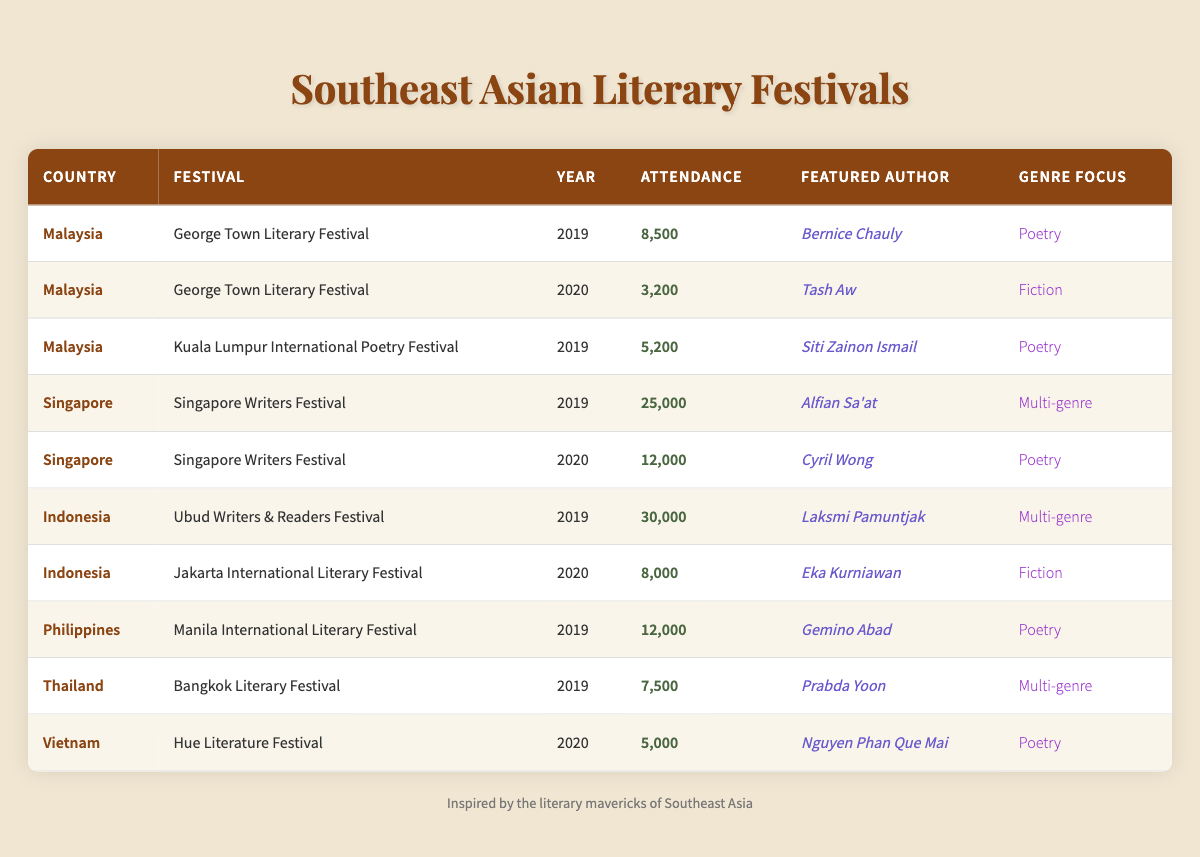What was the attendance at the George Town Literary Festival in 2019? According to the table, the George Town Literary Festival in 2019 had an attendance of 8,500.
Answer: 8,500 How many attendees did the Ubud Writers & Readers Festival have in 2019? The table shows that the Ubud Writers & Readers Festival in 2019 had an attendance of 30,000.
Answer: 30,000 Which country had the highest attendance at a literary festival in 2019? Looking at the attendance numbers for 2019, Indonesia recorded the highest with the Ubud Writers & Readers Festival having 30,000 attendees.
Answer: Indonesia What is the total attendance for Malaysian literary festivals listed in the table? Summing up the attendance from the George Town Literary Festival (8,500 + 3,200) and the Kuala Lumpur International Poetry Festival (5,200), the total attendance for Malaysian festivals is 8,500 + 3,200 + 5,200 = 16,900.
Answer: 16,900 Did the attendance increase from 2019 to 2020 for the Singapore Writers Festival? Comparing the attendance for the Singapore Writers Festival, it had 25,000 in 2019 and 12,000 in 2020. Since 12,000 is less than 25,000, the attendance did not increase.
Answer: No Which festival had a genre focus on Poetry and the highest attendance? The Ubud Writers & Readers Festival, which focuses on Multi-genre, is not relevant, so we look at the George Town Literary Festival (8,500) and Manila International Literary Festival (12,000). The Manila International Literary Festival had the highest attendance with 12,000 focusing on Poetry.
Answer: Manila International Literary Festival What was the average attendance across all literary festivals listed in the table? To find the average, first sum the attendance: (8500 + 3200 + 5200 + 25000 + 12000 + 30000 + 8000 + 12000 + 7500 + 5000) = 99300. There are 10 festivals, so the average attendance is 99300 / 10 = 9930.
Answer: 9930 Did any Filipino festival have a higher attendance than the Kuala Lumpur International Poetry Festival in 2019? The Kuala Lumpur International Poetry Festival had 5,200 attendees in 2019. The Manila International Literary Festival from the Philippines had 12,000 attendees, which is higher than 5,200.
Answer: Yes Which featured author had the lowest festival attendance in the dataset? To find this, we can look through the attendance numbers. The George Town Literary Festival in 2020 had Tash Aw as the featured author and only 3,200 attendees, the lowest.
Answer: Tash Aw 